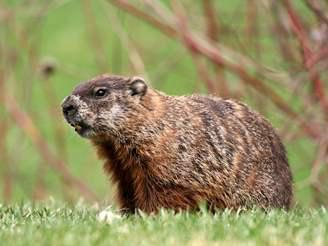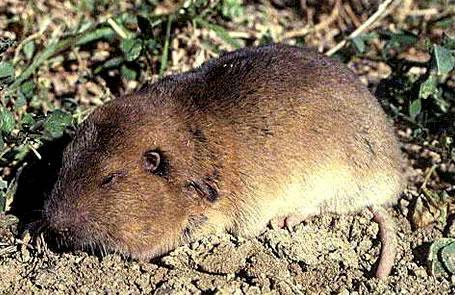The first image is the image on the left, the second image is the image on the right. Evaluate the accuracy of this statement regarding the images: "A marmot is partly in a hole.". Is it true? Answer yes or no. No. 